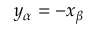<formula> <loc_0><loc_0><loc_500><loc_500>y _ { \alpha } = - x _ { \beta }</formula> 